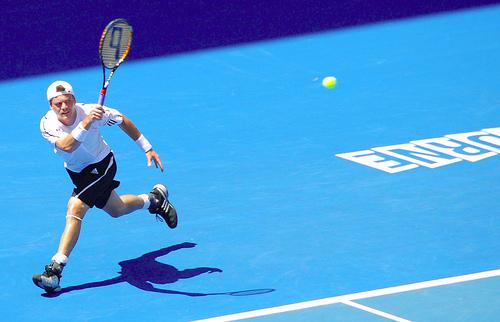Provide a brief description of what is happening in the image. A male tennis player just finished his forehand shot, holding a racket and wearing a white cap, black shorts, and a white shirt. Assess the quality of the objects in the image based on their image sizes. Some objects, like the tennis player and court lines, are large and detailed, while others, such as the tennis ball, wristbands, and racket logo, are smaller with lesser visible details. Analyze the image sentiment based on objects found within the image. The image sentiment is energetic and sports-focused, depicting a tennis player in action during a game. How could you describe the tennis court regarding the ground, lines, and other details? The tennis court's ground is blue with white striped boundary lines, blue letters on white squares, and the man's shadow cast on it. What type of tennis racket is the man holding, and does it have any logos or letters on it? The man is holding a Prince wooden tennis racket with a logo and lettering on the white strings. Estimate the number of tennis-related objects in the image. There are around 7 tennis-related objects, including the tennis ball, racket, court lines, and player. Explain the position and state of the tennis ball in the image. The tennis ball is green, small, and in mid-air, appearing to be flying through the air over the blue court. What are some notable details of the man's outfit in the image? The man is wearing black shorts with a white side stripe, a white short-sleeved shirt, a white baseball cap worn backward, and white sport wristbands on his wrists. Identify the primary colors seen in the image. Green, blue, yellow, white, and black are the main colors visible in the image. Identify the water bottle resting on the edge of the tennis court and note its color. No, it's not mentioned in the image. 